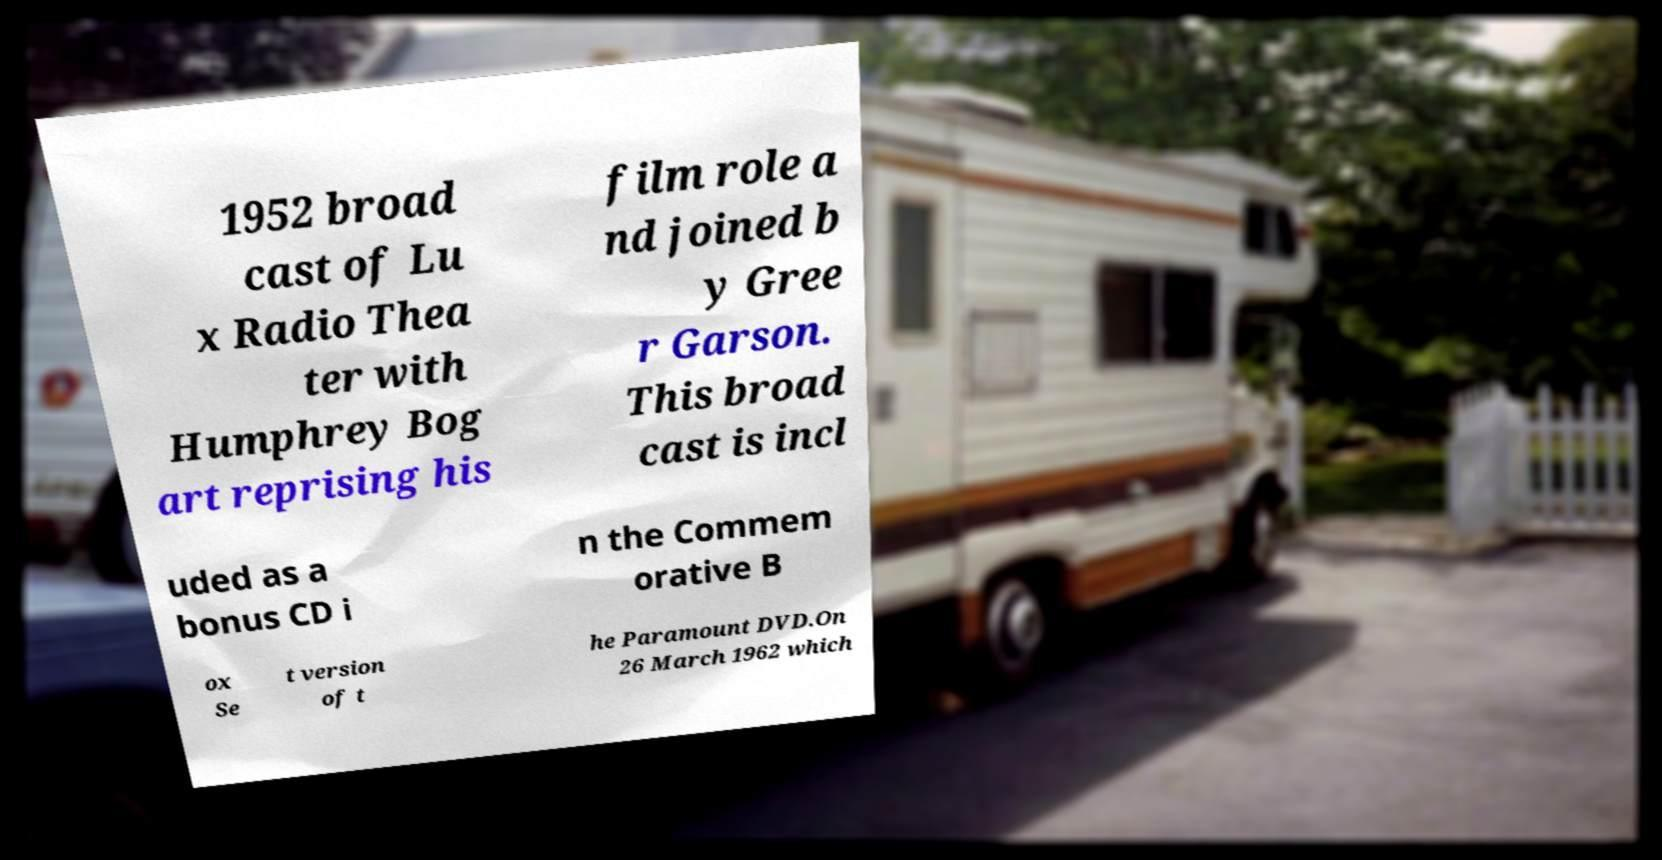What messages or text are displayed in this image? I need them in a readable, typed format. 1952 broad cast of Lu x Radio Thea ter with Humphrey Bog art reprising his film role a nd joined b y Gree r Garson. This broad cast is incl uded as a bonus CD i n the Commem orative B ox Se t version of t he Paramount DVD.On 26 March 1962 which 